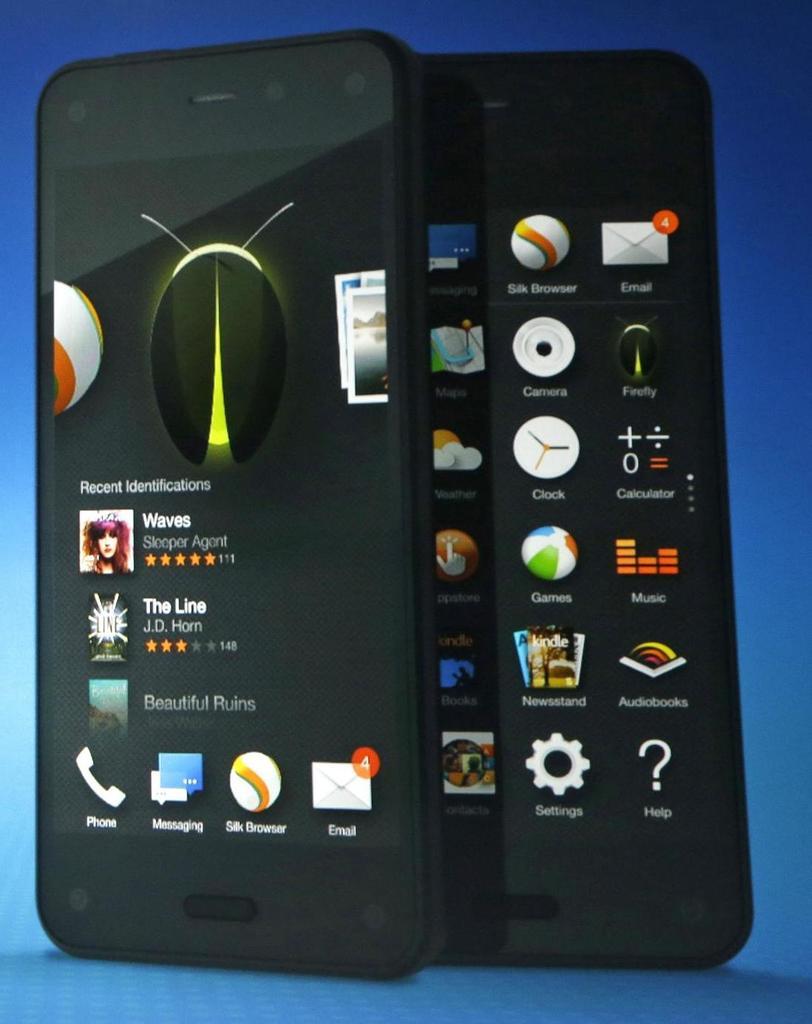What is the icon on the bottom right on the phone on the right?
Offer a very short reply. Help. How many new emails does this person have?
Your response must be concise. 4. 